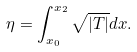Convert formula to latex. <formula><loc_0><loc_0><loc_500><loc_500>\eta = \int _ { x _ { 0 } } ^ { x _ { 2 } } \sqrt { | T | } d x .</formula> 